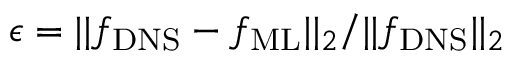Convert formula to latex. <formula><loc_0><loc_0><loc_500><loc_500>\epsilon = | | { f _ { D N S } } - { f _ { M L } } | | _ { 2 } / | | { f _ { D N S } } | | _ { 2 }</formula> 